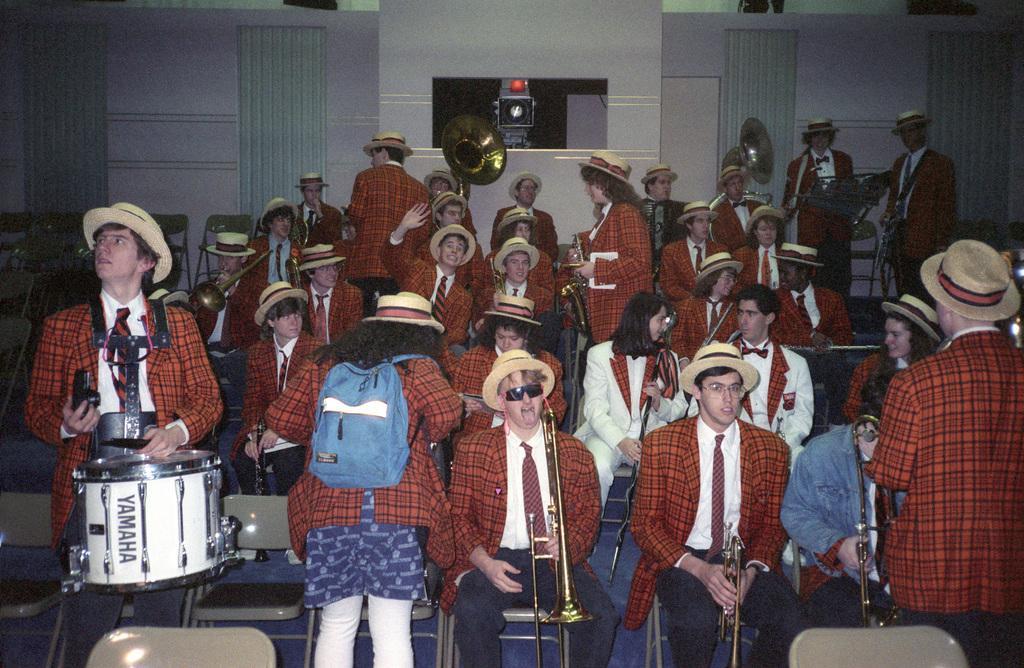In one or two sentences, can you explain what this image depicts? In this image there are group of persons wearing similar dress playing musical instruments. 